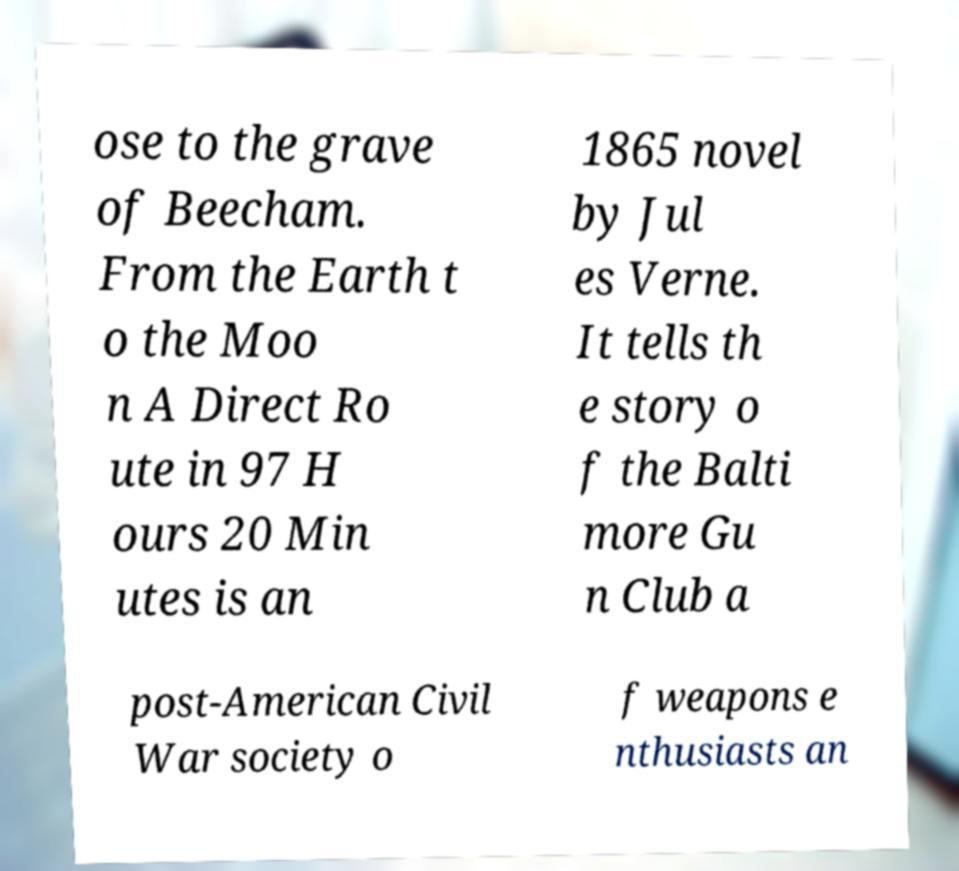What messages or text are displayed in this image? I need them in a readable, typed format. ose to the grave of Beecham. From the Earth t o the Moo n A Direct Ro ute in 97 H ours 20 Min utes is an 1865 novel by Jul es Verne. It tells th e story o f the Balti more Gu n Club a post-American Civil War society o f weapons e nthusiasts an 